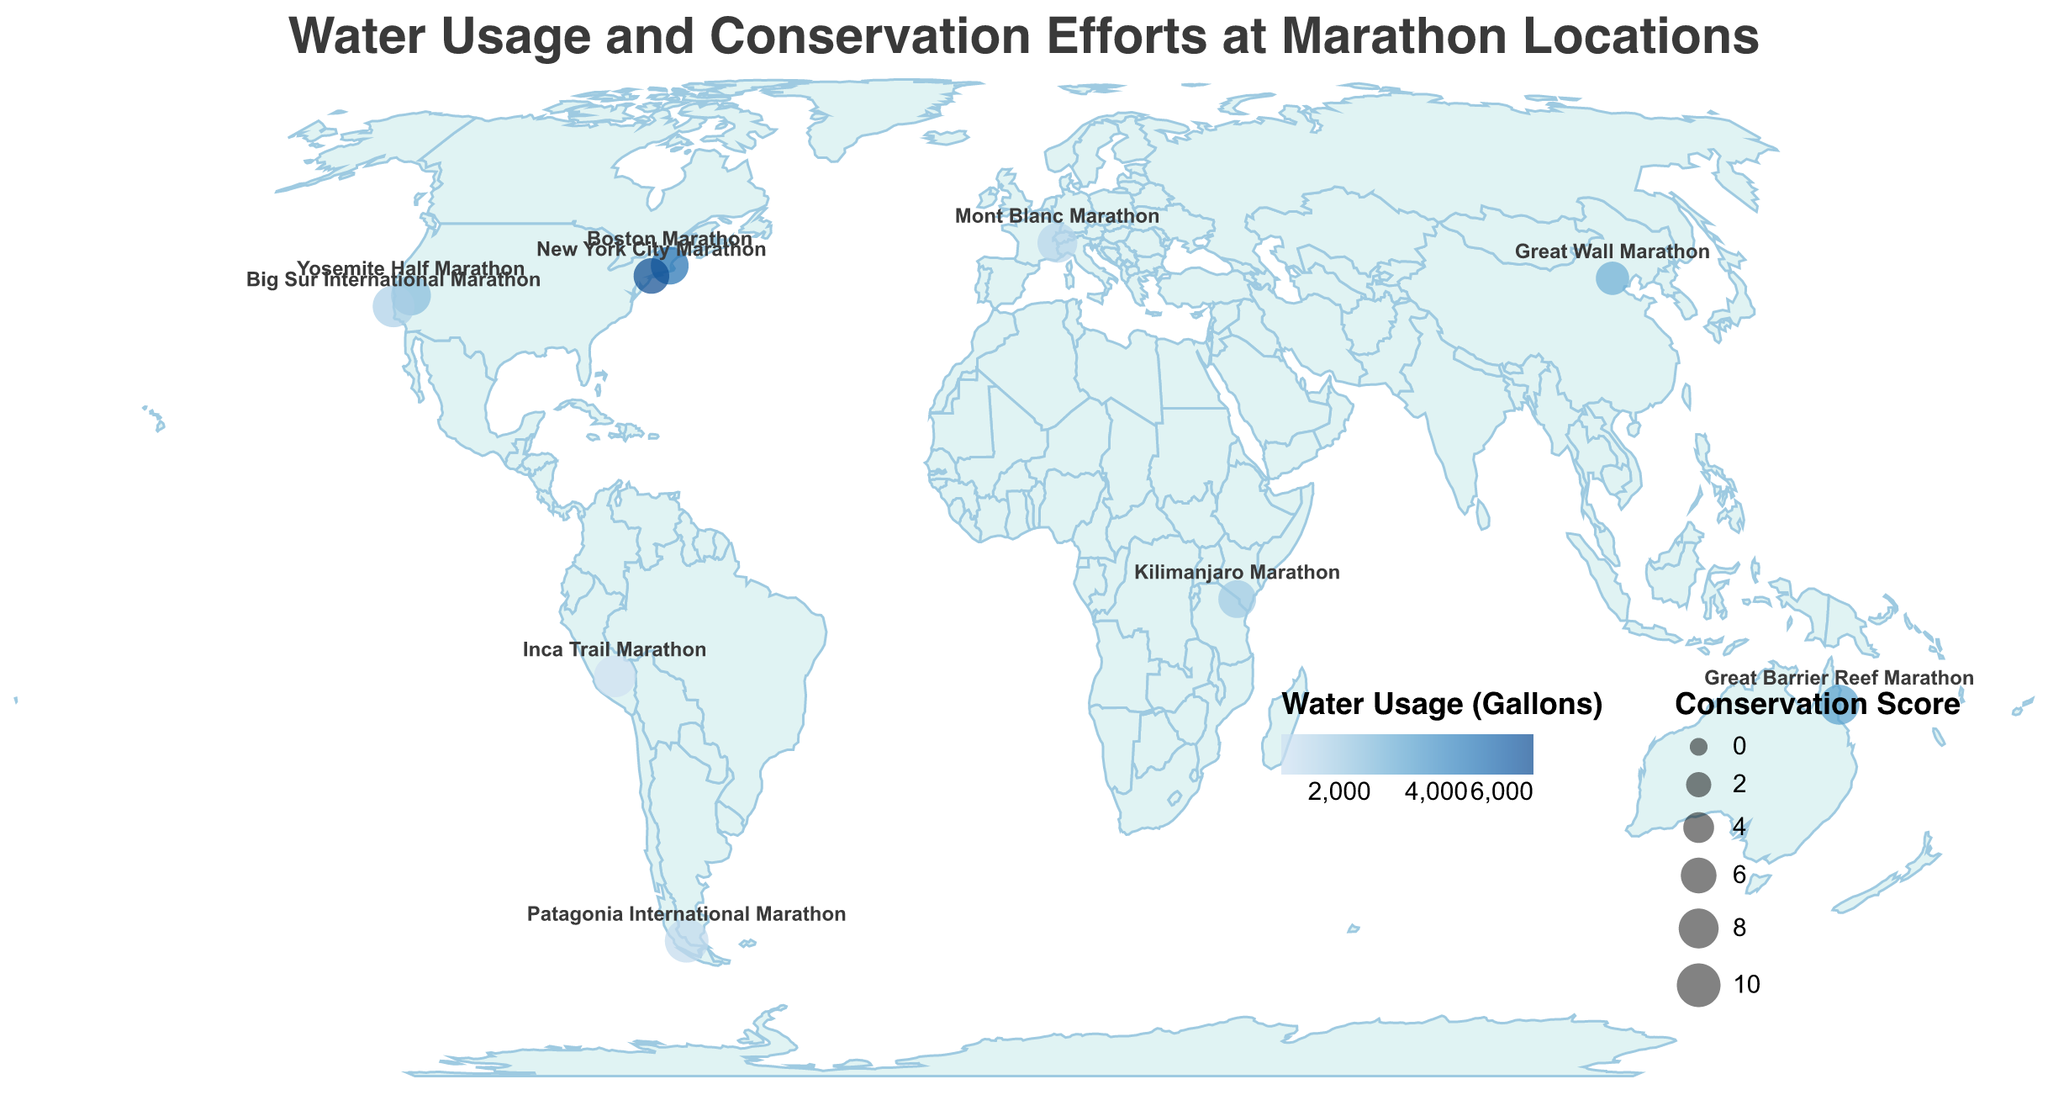What's the title of the figure? The title is displayed at the top of the figure in large text. It reads "Water Usage and Conservation Efforts at Marathon Locations".
Answer: Water Usage and Conservation Efforts at Marathon Locations How many race locations are shown on the map? By counting the number of circles on the map, each representing a race location, we see there are 10 locations.
Answer: 10 Which marathon has the highest water usage? The color of the circles represents water usage in gallons, with darker colors indicating higher usage. The New York City Marathon, with the darkest blue circle, has the highest water usage of 6000 gallons.
Answer: New York City Marathon Which marathon has the highest conservation efforts score and what is their primary conservation method? The size of the circles represents the conservation efforts score, with larger circles indicating higher scores. The Patagonia International Marathon has the largest circle and a conservation efforts score of 10. It's labelled with the primary conservation method "Natural water sources".
Answer: Patagonia International Marathon, Natural water sources What is the primary conservation method at the Yosemite Half Marathon? Access the tooltip information by looking at the location label "Yosemite Half Marathon". The tooltip indicates that the primary conservation method is "Rainwater harvesting".
Answer: Rainwater harvesting What is the average water usage for the marathons with a conservation efforts score of 8? Identify the marathons with a conservation score of 8: Yosemite Half Marathon, Great Barrier Reef Marathon, Mont Blanc Marathon. Their respective water usages are 2500, 3500, and 1500 gallons. Sum these values: 2500 + 3500 + 1500 = 7500 gallons. Average it by dividing by 3: 7500 / 3 = 2500 gallons.
Answer: 2500 gallons Which race locations are in the Southern Hemisphere? Look at the latitude of each location. Locations with negative latitude values are in the Southern Hemisphere. They are the Patagonia International Marathon (latitude -51.2657), Inca Trail Marathon (latitude -13.1631), and Great Barrier Reef Marathon (latitude -16.9203).
Answer: Patagonia International Marathon, Inca Trail Marathon, Great Barrier Reef Marathon Compare the water usage between marathons in North America and South America. Which continent uses more water? Summarize the water usage for locations in each continent: North America (Yosemite 2500, Boston 5000, New York 6000, Big Sur 1800) and South America (Patagonia 1200, Inca Trail 800). North America's total: 2500 + 5000 + 6000 + 1800 = 15300 gallons. South America's total: 1200 + 800 = 2000 gallons. North America uses more water.
Answer: North America Which location has the lowest water usage and what is its conservation score? The circle with the lightest color indicates the lowest water usage. The Inca Trail Marathon has the lightest circle with a water usage of 800 gallons and a conservation score of 9.
Answer: Inca Trail Marathon, Conservation score 9 How does the conservation efforts score affect the size of the circles on the map? The size of each circle is directly proportional to the conservation efforts score. Larger circles represent higher scores and smaller circles represent lower scores. The Mont Blanc Marathon, for instance, has a score of 8 and a medium-to-large circle size.
Answer: Larger circles indicate higher conservation scores, while smaller circles indicate lower scores 